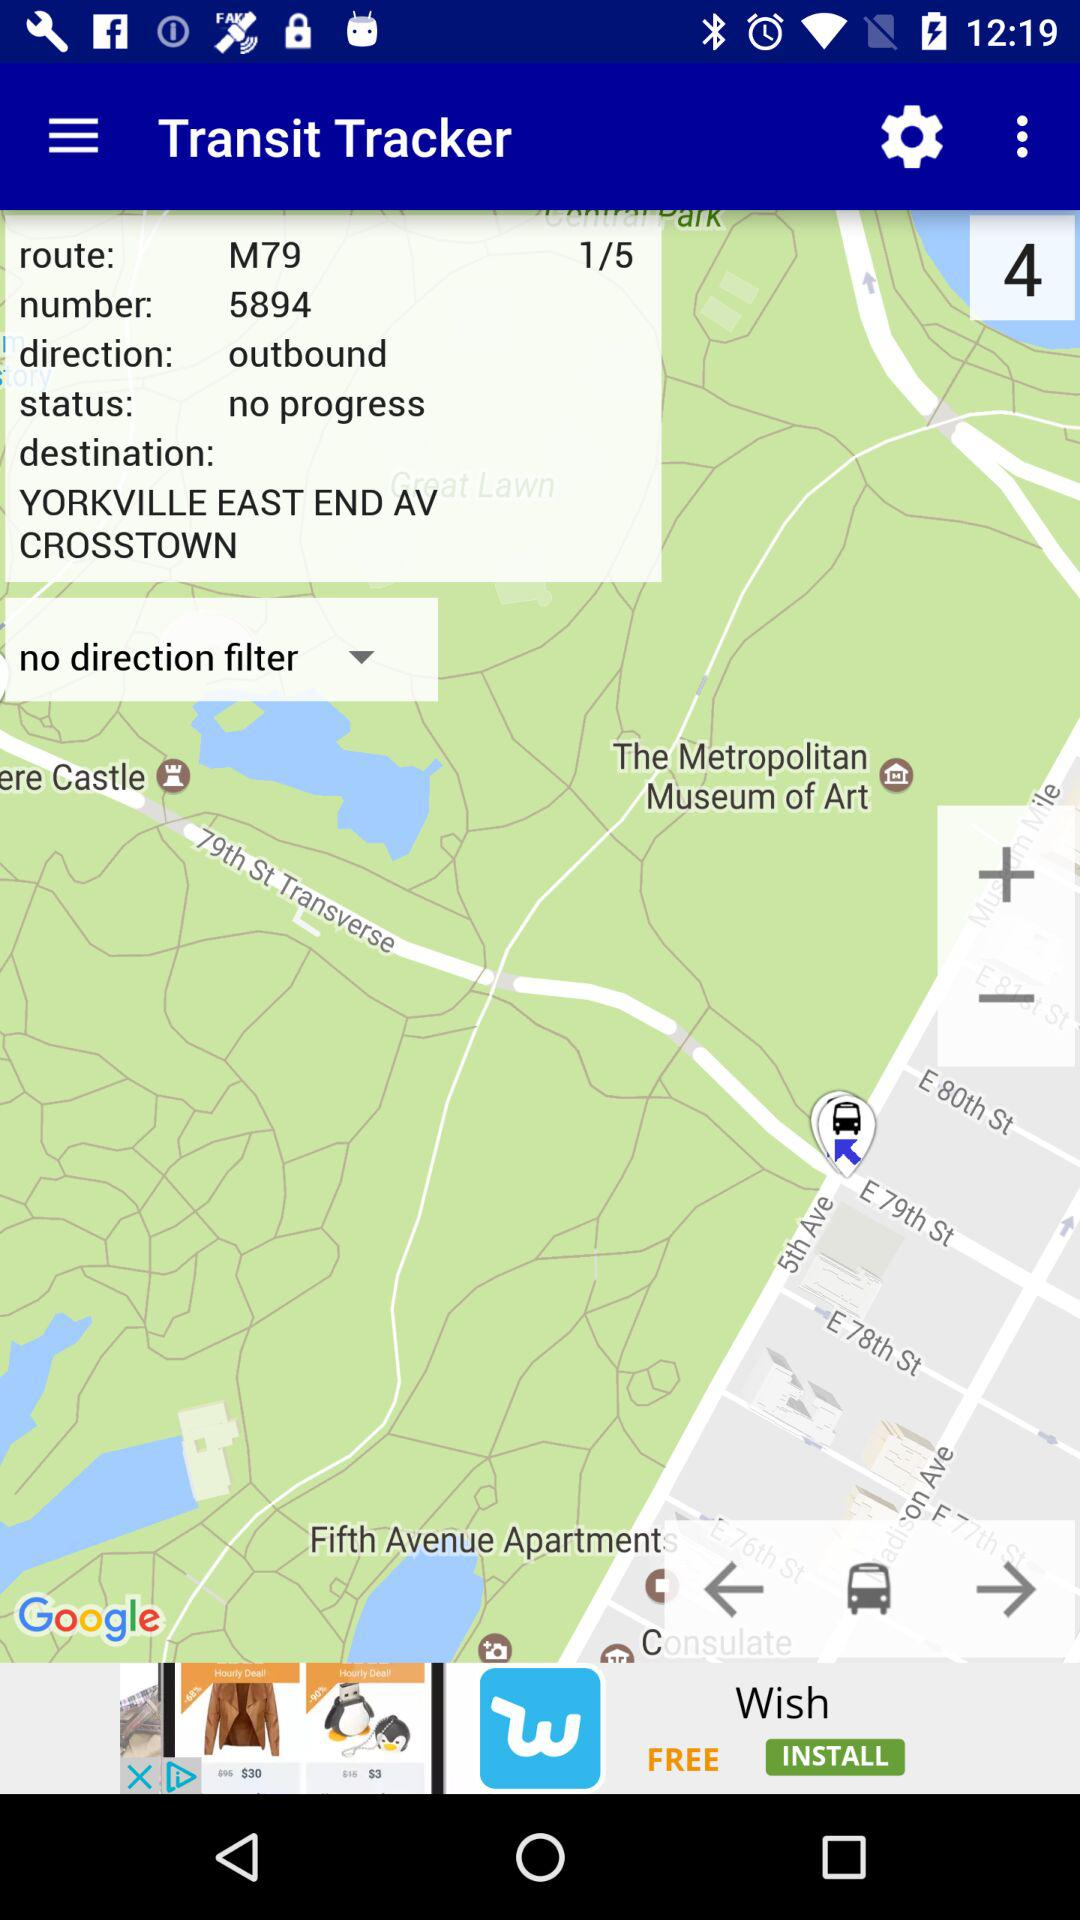What is the status in the tracker? The status in the tracker is "no progress". 